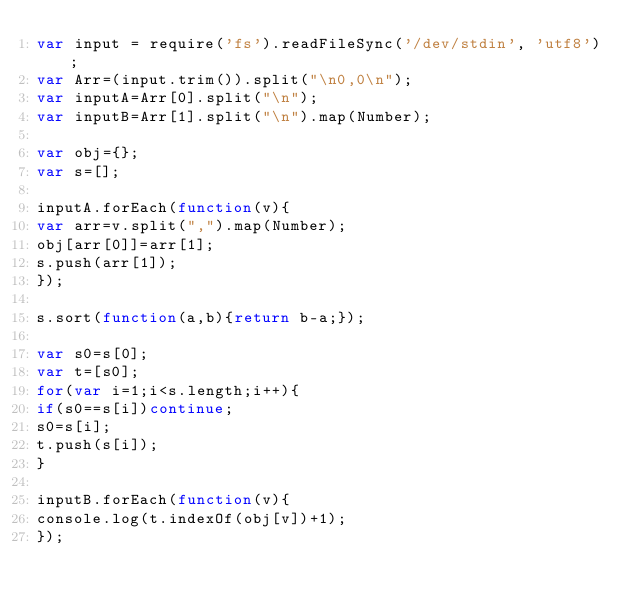Convert code to text. <code><loc_0><loc_0><loc_500><loc_500><_JavaScript_>var input = require('fs').readFileSync('/dev/stdin', 'utf8');
var Arr=(input.trim()).split("\n0,0\n");
var inputA=Arr[0].split("\n");
var inputB=Arr[1].split("\n").map(Number);

var obj={};
var s=[];

inputA.forEach(function(v){
var arr=v.split(",").map(Number);
obj[arr[0]]=arr[1];
s.push(arr[1]);
});

s.sort(function(a,b){return b-a;});

var s0=s[0];
var t=[s0];
for(var i=1;i<s.length;i++){
if(s0==s[i])continue;
s0=s[i];
t.push(s[i]);
}

inputB.forEach(function(v){
console.log(t.indexOf(obj[v])+1);
});</code> 